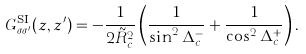Convert formula to latex. <formula><loc_0><loc_0><loc_500><loc_500>G _ { \sigma \sigma ^ { \prime } } ^ { \text {SI} } ( z , z ^ { \prime } ) = - \frac { 1 } { 2 \tilde { R } _ { c } ^ { 2 } } \left ( \frac { 1 } { \sin ^ { 2 } \Delta _ { c } ^ { - } } + \frac { 1 } { \cos ^ { 2 } \Delta _ { c } ^ { + } } \right ) .</formula> 